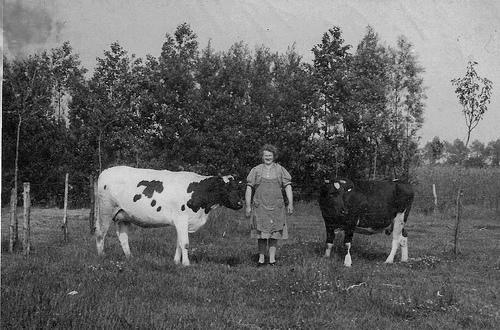How many cows are there?
Give a very brief answer. 2. How many legs does the cow have?
Give a very brief answer. 4. 